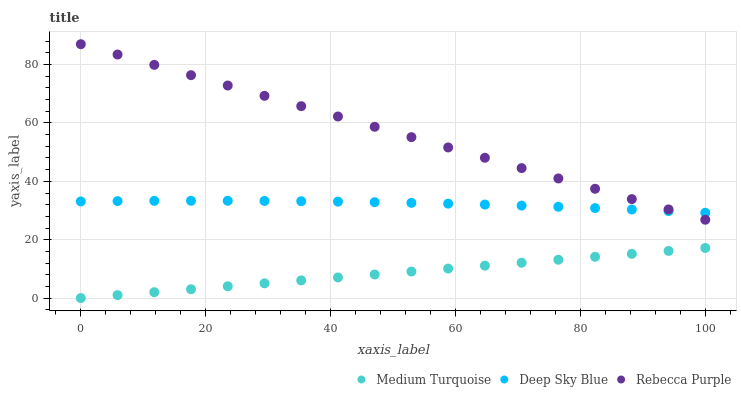Does Medium Turquoise have the minimum area under the curve?
Answer yes or no. Yes. Does Rebecca Purple have the maximum area under the curve?
Answer yes or no. Yes. Does Rebecca Purple have the minimum area under the curve?
Answer yes or no. No. Does Medium Turquoise have the maximum area under the curve?
Answer yes or no. No. Is Medium Turquoise the smoothest?
Answer yes or no. Yes. Is Deep Sky Blue the roughest?
Answer yes or no. Yes. Is Rebecca Purple the smoothest?
Answer yes or no. No. Is Rebecca Purple the roughest?
Answer yes or no. No. Does Medium Turquoise have the lowest value?
Answer yes or no. Yes. Does Rebecca Purple have the lowest value?
Answer yes or no. No. Does Rebecca Purple have the highest value?
Answer yes or no. Yes. Does Medium Turquoise have the highest value?
Answer yes or no. No. Is Medium Turquoise less than Deep Sky Blue?
Answer yes or no. Yes. Is Rebecca Purple greater than Medium Turquoise?
Answer yes or no. Yes. Does Rebecca Purple intersect Deep Sky Blue?
Answer yes or no. Yes. Is Rebecca Purple less than Deep Sky Blue?
Answer yes or no. No. Is Rebecca Purple greater than Deep Sky Blue?
Answer yes or no. No. Does Medium Turquoise intersect Deep Sky Blue?
Answer yes or no. No. 